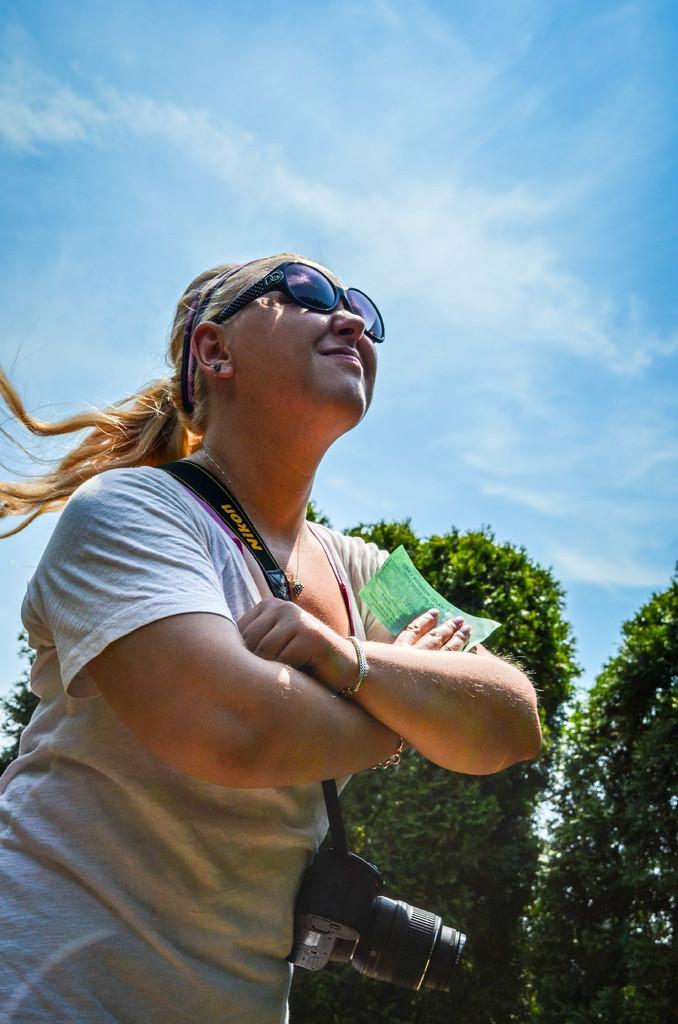How would you summarize this image in a sentence or two? In this image I can see a person standing and wearing white color shirt. The person is also wearing a camera and holding a paper. Background I can see few trees in green color and sky in blue and white color. 